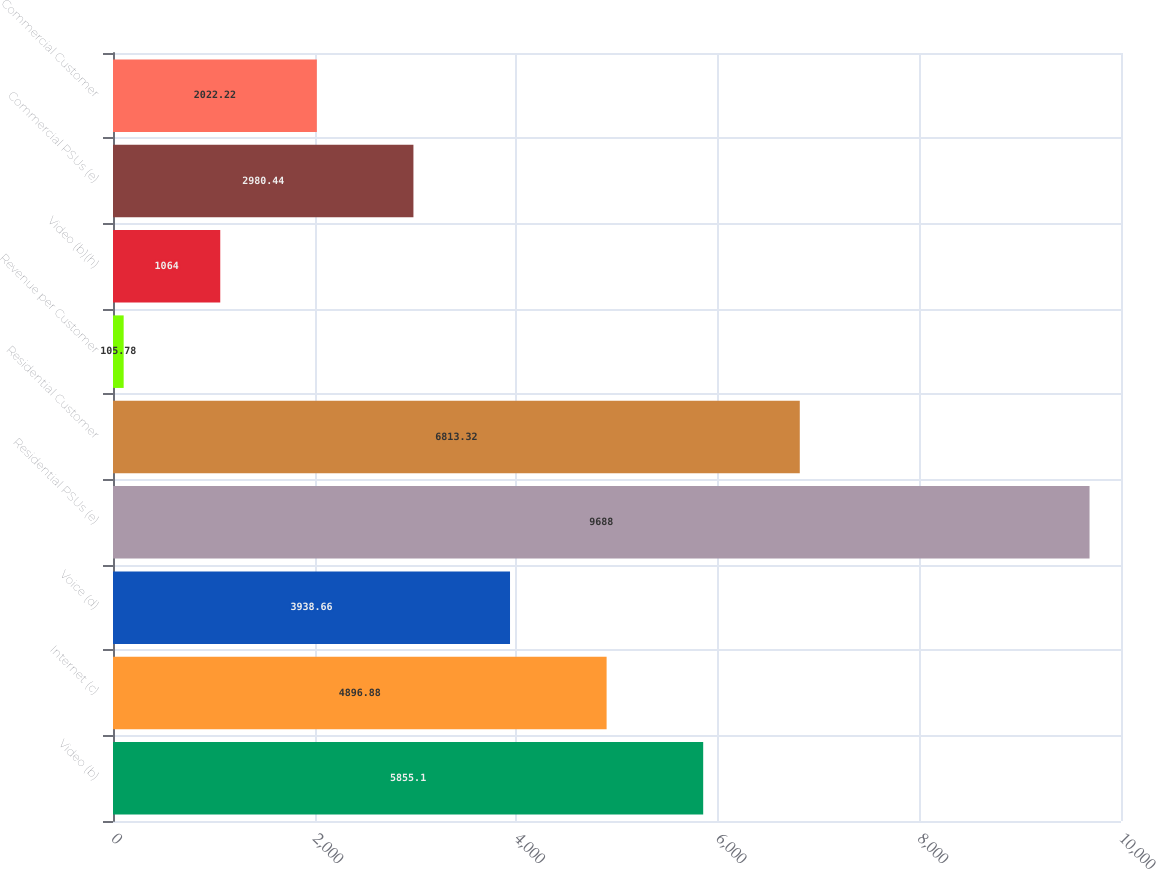Convert chart to OTSL. <chart><loc_0><loc_0><loc_500><loc_500><bar_chart><fcel>Video (b)<fcel>Internet (c)<fcel>Voice (d)<fcel>Residential PSUs (e)<fcel>Residential Customer<fcel>Revenue per Customer<fcel>Video (b)(h)<fcel>Commercial PSUs (e)<fcel>Commercial Customer<nl><fcel>5855.1<fcel>4896.88<fcel>3938.66<fcel>9688<fcel>6813.32<fcel>105.78<fcel>1064<fcel>2980.44<fcel>2022.22<nl></chart> 